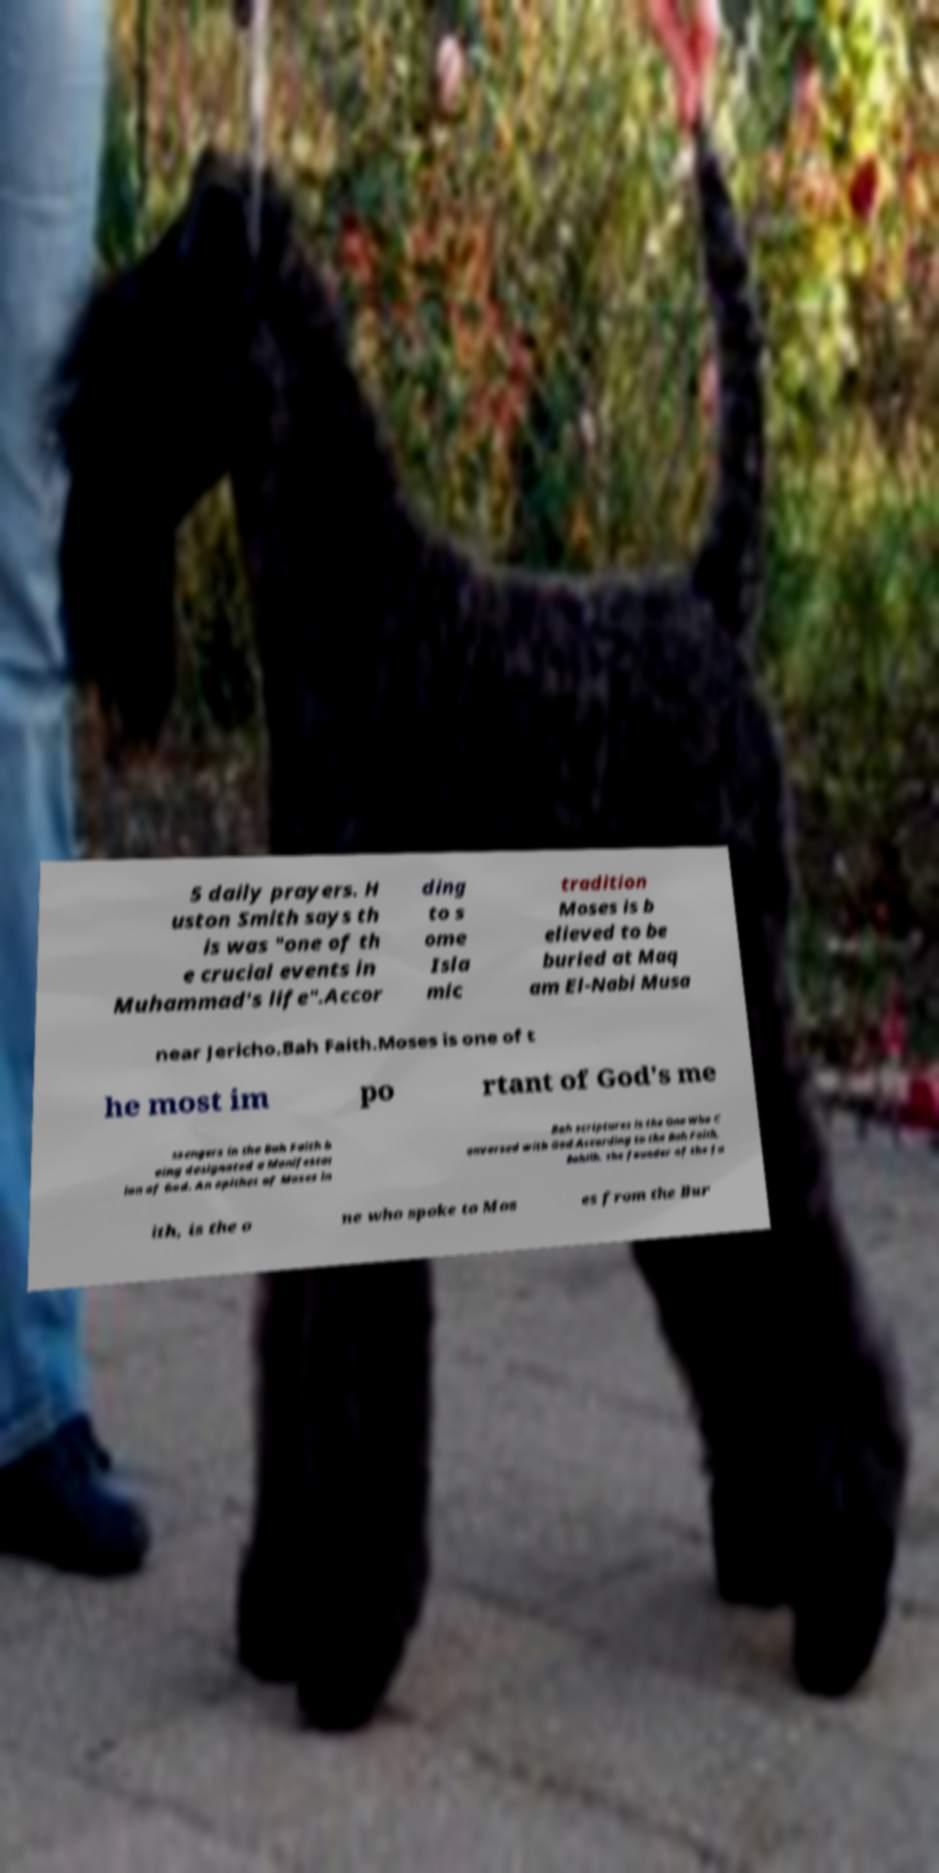Please identify and transcribe the text found in this image. 5 daily prayers. H uston Smith says th is was "one of th e crucial events in Muhammad's life".Accor ding to s ome Isla mic tradition Moses is b elieved to be buried at Maq am El-Nabi Musa near Jericho.Bah Faith.Moses is one of t he most im po rtant of God's me ssengers in the Bah Faith b eing designated a Manifestat ion of God. An epithet of Moses in Bah scriptures is the One Who C onversed with God.According to the Bah Faith, Bahllh, the founder of the fa ith, is the o ne who spoke to Mos es from the Bur 